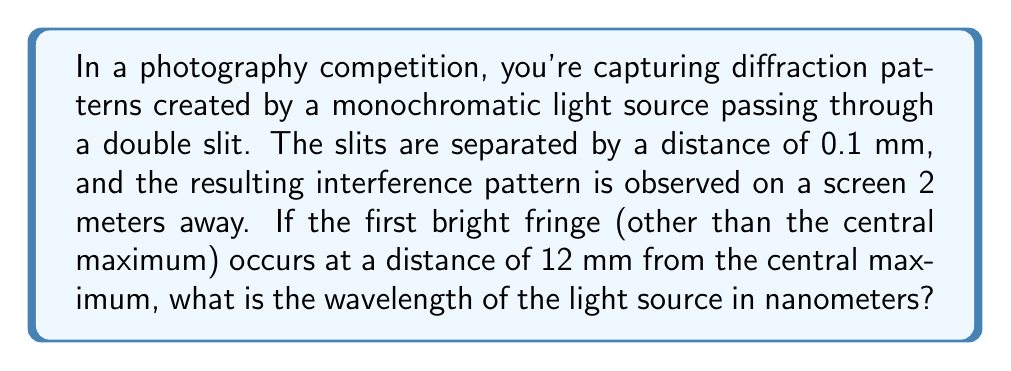Solve this math problem. Let's approach this step-by-step using the double-slit interference formula:

1) The formula for double-slit interference is:

   $$d \sin \theta = m\lambda$$

   Where:
   $d$ = slit separation
   $\theta$ = angle to the mth bright fringe
   $m$ = order of the bright fringe (1 for the first bright fringe)
   $\lambda$ = wavelength of light

2) We're given:
   $d = 0.1 \text{ mm} = 1 \times 10^{-4} \text{ m}$
   Distance to screen $L = 2 \text{ m}$
   Distance to first bright fringe $y = 12 \text{ mm} = 0.012 \text{ m}$

3) We need to find $\sin \theta$. For small angles, $\sin \theta \approx \tan \theta = \frac{y}{L}$:

   $$\sin \theta \approx \frac{0.012}{2} = 0.006$$

4) Now we can substitute into our formula:

   $$(1 \times 10^{-4}) (0.006) = 1\lambda$$

5) Solve for $\lambda$:

   $$\lambda = 6 \times 10^{-7} \text{ m} = 600 \text{ nm}$$
Answer: 600 nm 